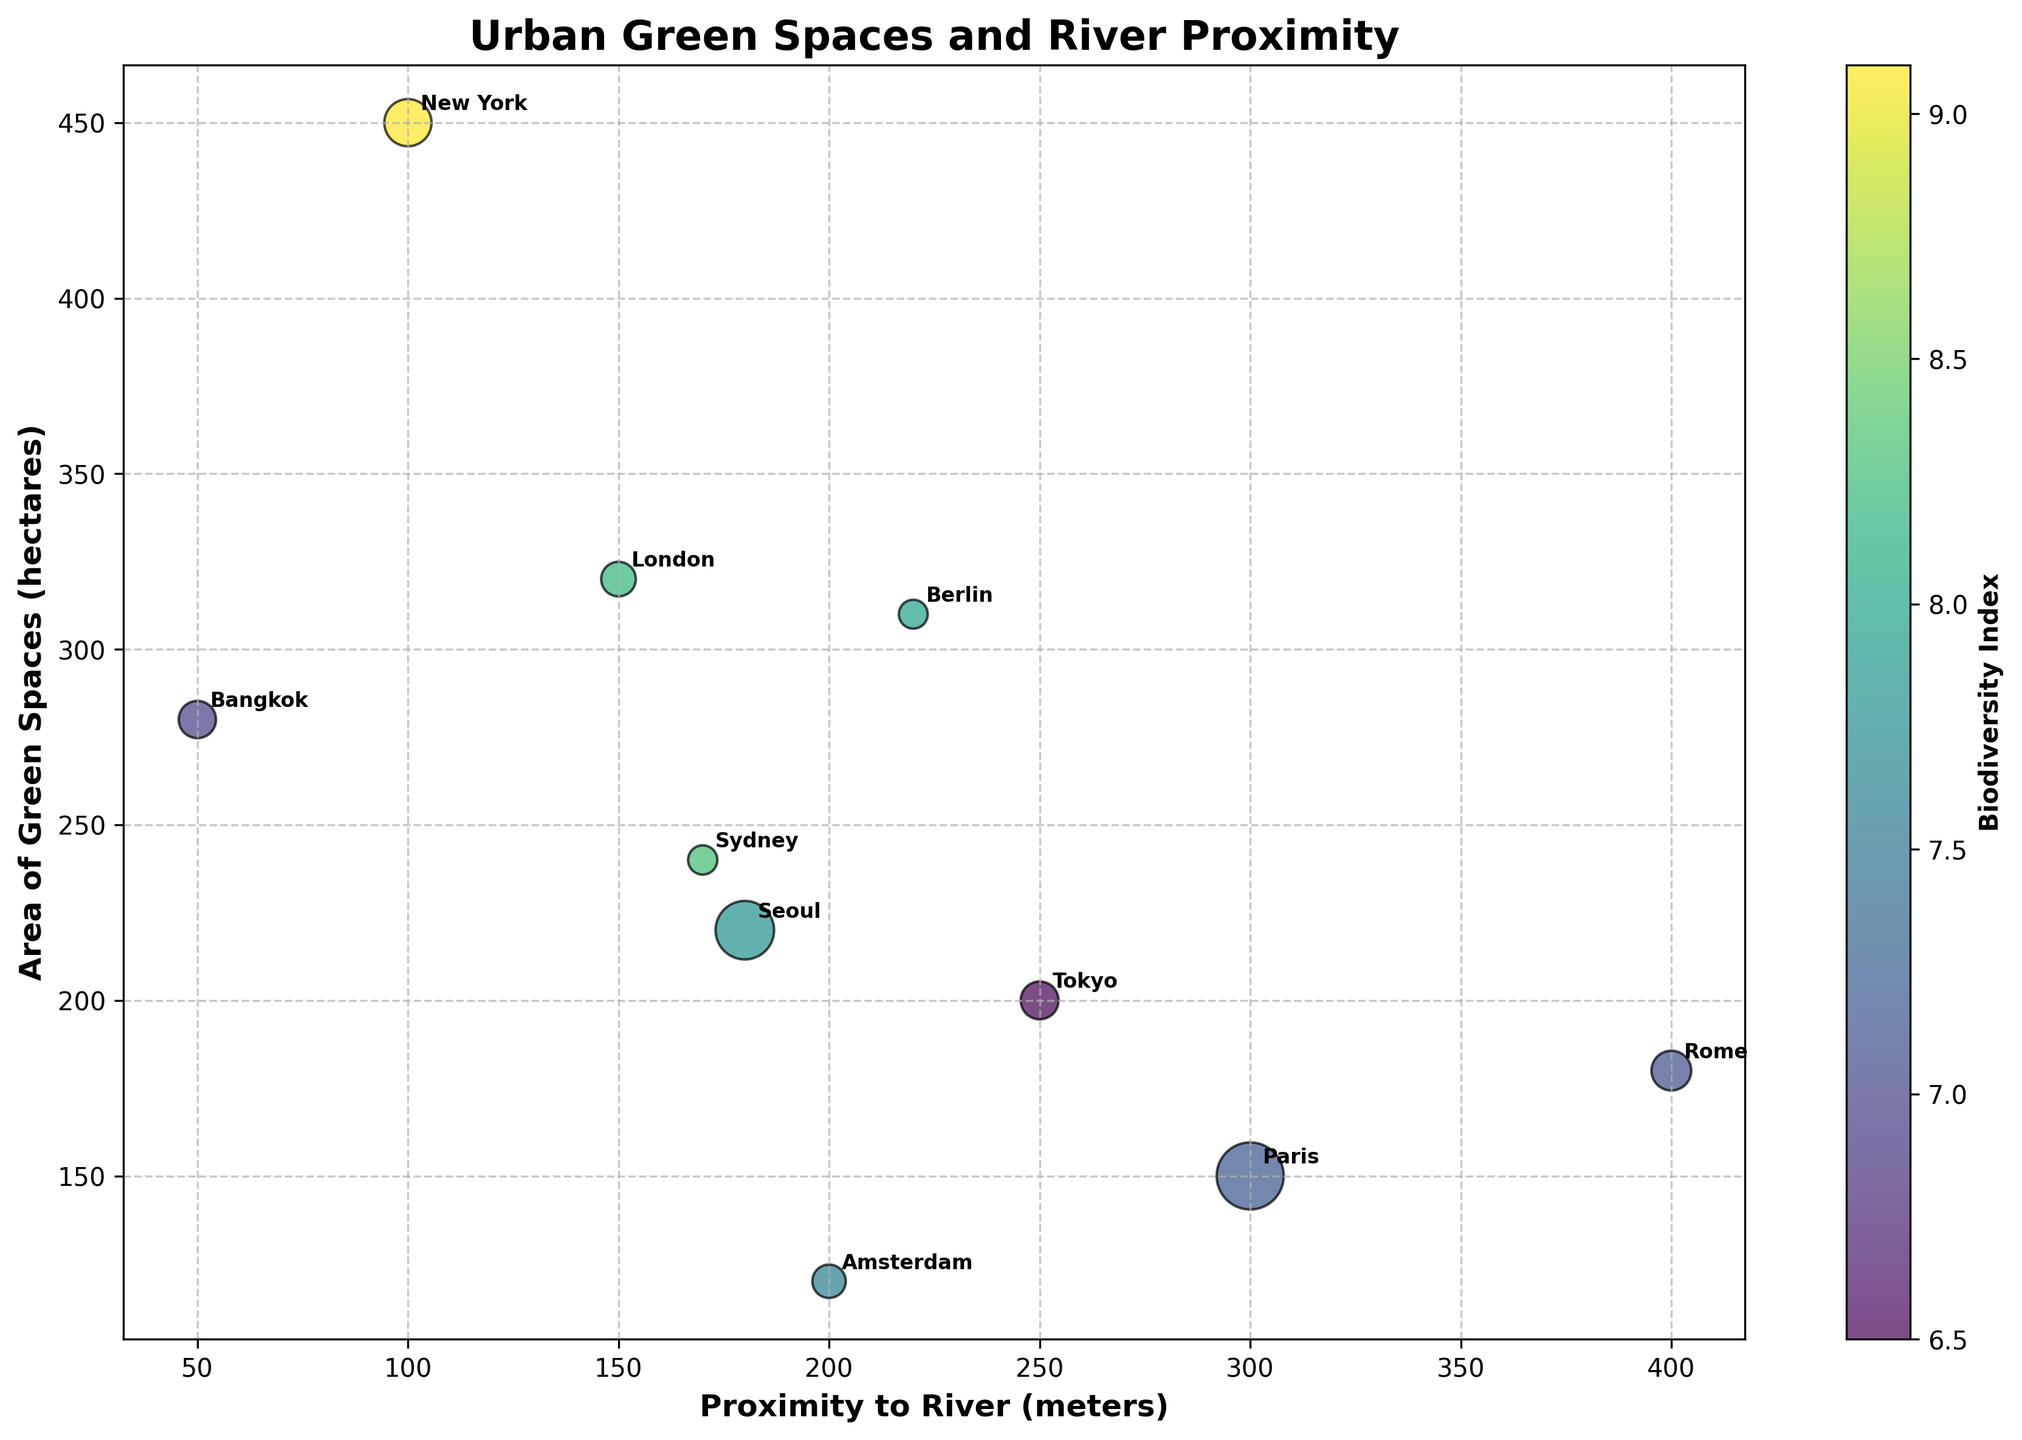Which city has the largest area of green spaces? The largest circle on the y-axis represents the area of green spaces. By examining the figure, New York has the largest green space area with 450 hectares.
Answer: New York What is the title of the bubble chart? The title is clearly mentioned at the top of the chart and states what the bubble chart represents.
Answer: Urban Green Spaces and River Proximity Which city is closest to a river? The x-axis represents proximity to the river in meters. Bangkok, with the smallest x-coordinate (50 meters), is closest to the river.
Answer: Bangkok How does the Biodiversity Index correlate with the colors of the bubbles? The color bar to the right of the chart shows the correlation between colors and the Biodiversity Index. Darker colors tend to represent higher Biodiversity Index values. For example, New York has one of the darkest colors and a high Biodiversity Index of 9.1.
Answer: Darker colors represent higher Biodiversity Index values Are there more green spaces in Amsterdam or Tokyo? By comparing the positions of Amsterdam and Tokyo on the y-axis (Area of Green Spaces), Amsterdam (120 hectares) and Tokyo (200 hectares). Tokyo has more green spaces than Amsterdam.
Answer: Tokyo Which city has the highest population density? The size of the bubbles represents population density. The largest bubble corresponds to Paris, indicating the highest population density of 21,000 people per square km.
Answer: Paris What is the Biodiversity Index of Berlin? By identifying Berlin in the plot and noting the bubble color, which can be cross-referenced with the color bar. Berlin's bubble has a brightness corresponding to a Biodiversity Index of 8.0.
Answer: 8.0 Are urban green spaces generally larger when closer to or further from river systems? By examining the overall trend on the chart, there seems to be no clear trend that smaller or larger areas of green spaces consistently align with proximity to the river.
Answer: No clear trend Which city has the smallest area of green spaces yet considerable proximity to the river? By looking at the smallest y-coordinate values (area of green spaces) among cities close to the x-axis origin. Paris has 150 hectares and is 300 meters away from the river, qualifying it as having the smallest green area with considerable river proximity.
Answer: Paris What's the average population density of the cities closer than 200 meters to the river? Cities within 200 meters to the river are Amsterdam, London, New York, Seoul, Sydney, and Bangkok. Their population densities are 5220, 5600, 10400, 16000, 4000, and 6500, respectively. The average is (5220 + 5600 + 10400 + 16000 + 4000 + 6500) / 6 = 7940 people per sq km.
Answer: 7940 people per sq km 